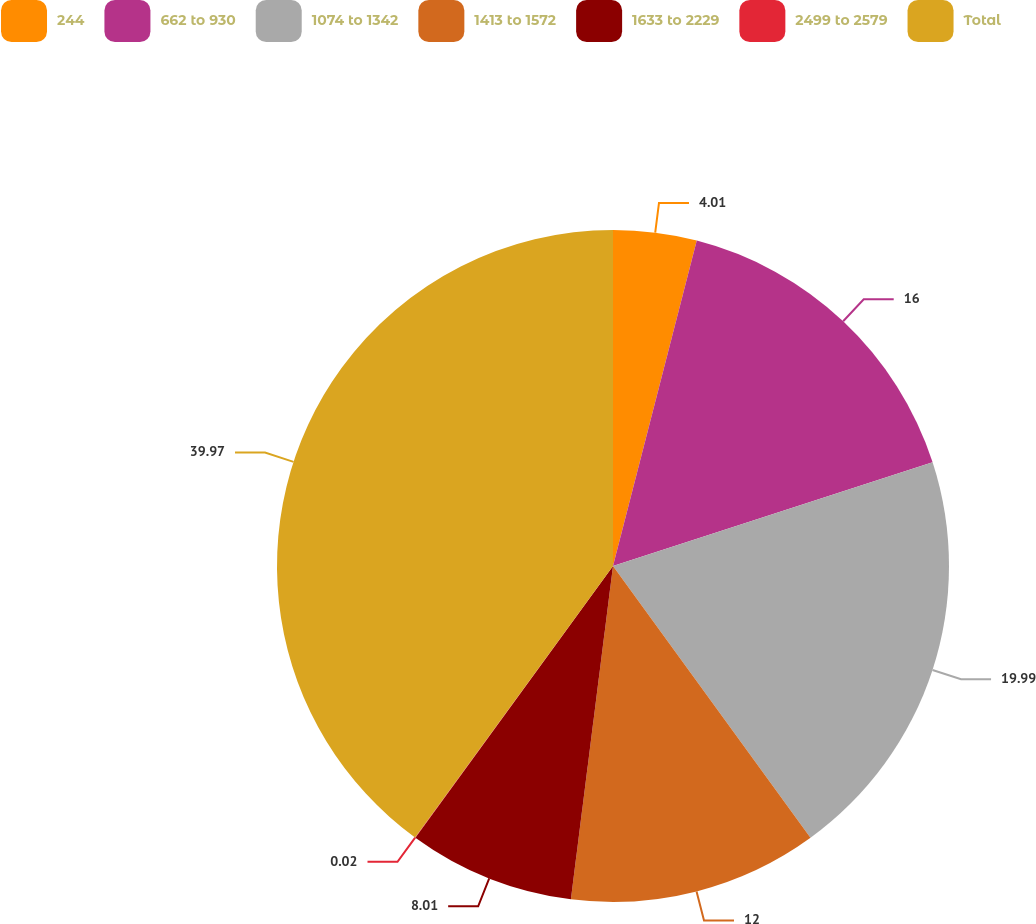<chart> <loc_0><loc_0><loc_500><loc_500><pie_chart><fcel>244<fcel>662 to 930<fcel>1074 to 1342<fcel>1413 to 1572<fcel>1633 to 2229<fcel>2499 to 2579<fcel>Total<nl><fcel>4.01%<fcel>16.0%<fcel>19.99%<fcel>12.0%<fcel>8.01%<fcel>0.02%<fcel>39.97%<nl></chart> 